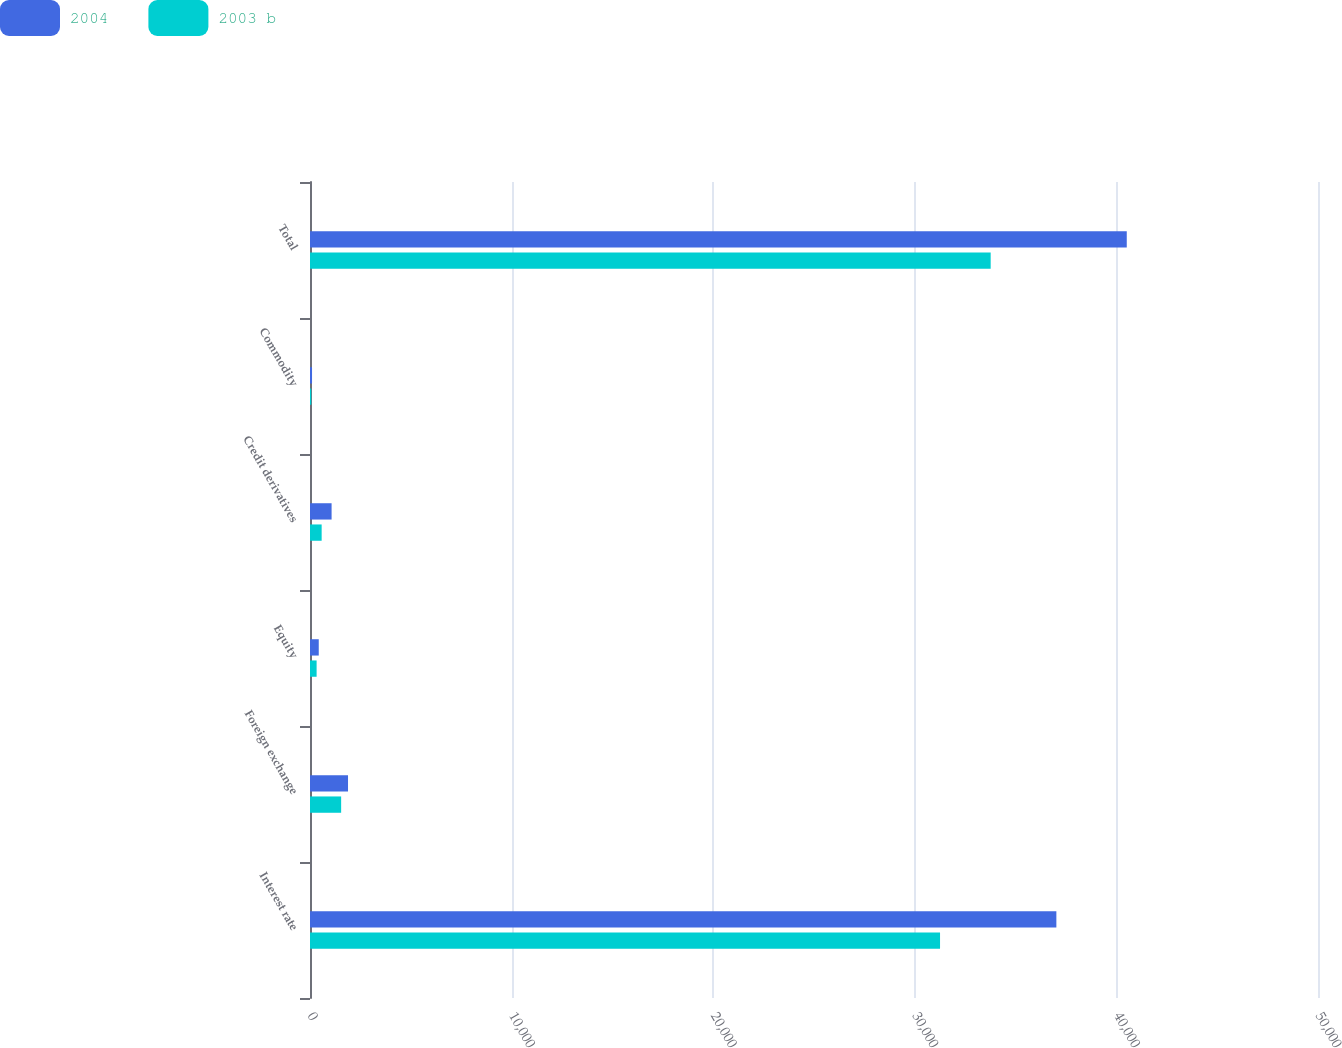<chart> <loc_0><loc_0><loc_500><loc_500><stacked_bar_chart><ecel><fcel>Interest rate<fcel>Foreign exchange<fcel>Equity<fcel>Credit derivatives<fcel>Commodity<fcel>Total<nl><fcel>2004<fcel>37022<fcel>1886<fcel>434<fcel>1071<fcel>101<fcel>40514<nl><fcel>2003 b<fcel>31252<fcel>1545<fcel>328<fcel>578<fcel>61<fcel>33764<nl></chart> 